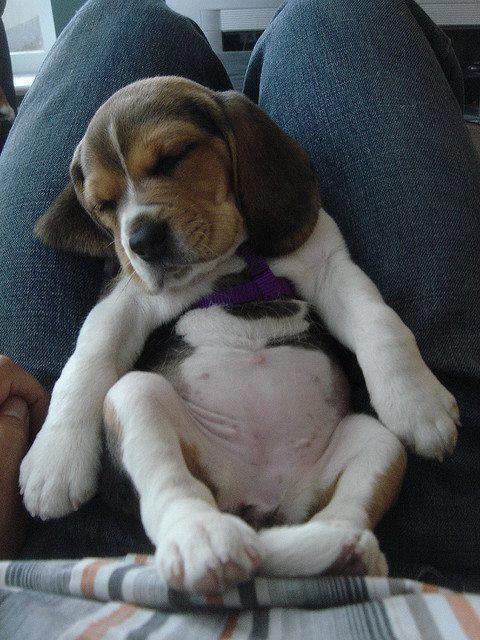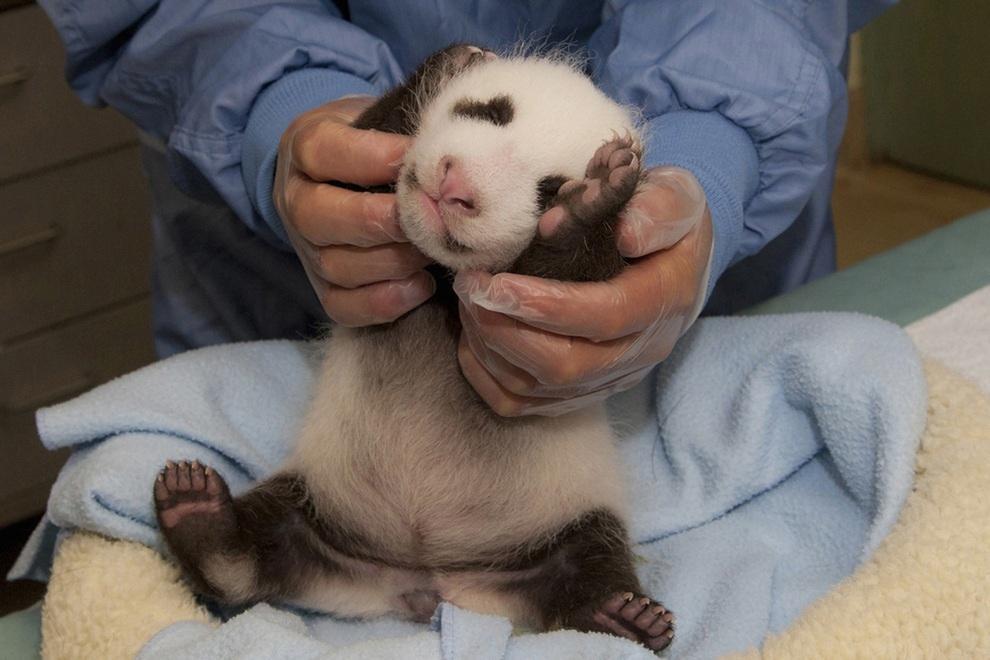The first image is the image on the left, the second image is the image on the right. Given the left and right images, does the statement "All dogs' stomachs are visible." hold true? Answer yes or no. Yes. 